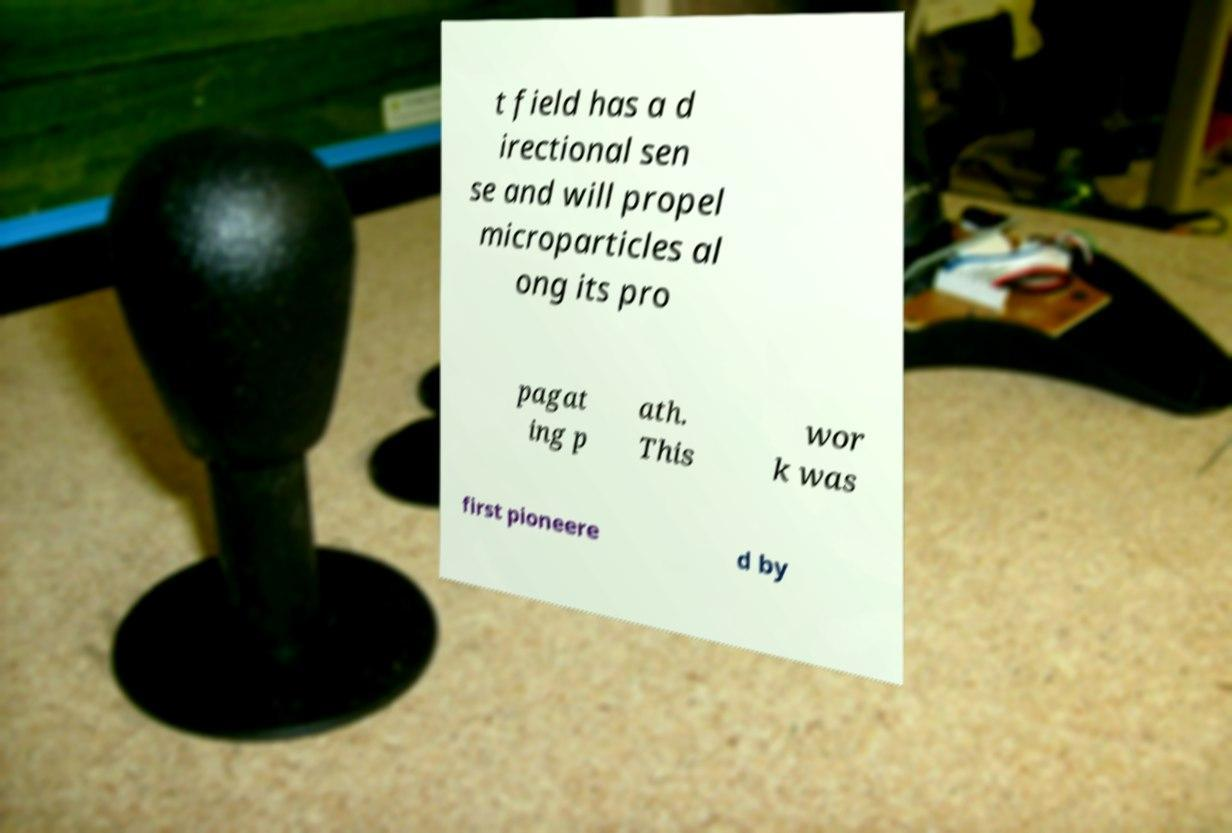Can you read and provide the text displayed in the image?This photo seems to have some interesting text. Can you extract and type it out for me? t field has a d irectional sen se and will propel microparticles al ong its pro pagat ing p ath. This wor k was first pioneere d by 